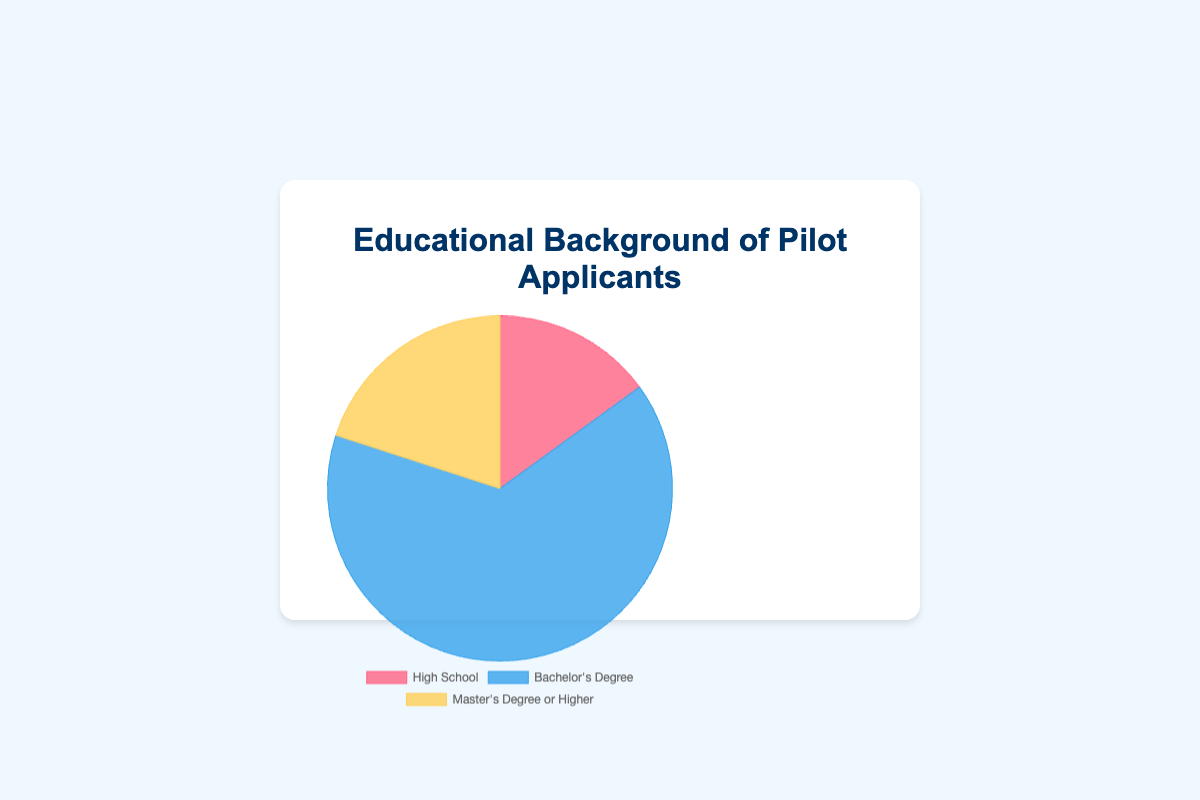What percentage of pilot applicants have at least a Bachelor's Degree? To find the percentage of applicants with at least a Bachelor's Degree, we need to sum the percentages of those with a Bachelor's Degree and those with a Master's Degree or Higher. Bachelor's Degree is 65% and Master's Degree or Higher is 20%, so the sum is 65% + 20% = 85%
Answer: 85% Which educational background has the highest percentage of pilot applicants? By comparing the given percentages, we see that the Bachelor's Degree category has the highest percentage of applicants at 65%
Answer: Bachelor's Degree How does the percentage of applicants with a Master's Degree or Higher compare to those with just a High School diploma? The percentage of applicants with a Master's Degree or Higher is 20%, while those with a High School diploma is 15%. Therefore, the percentage for Master's Degree or Higher is 5% higher.
Answer: 5% higher What is the proportion of applicants with a Bachelor's Degree to those with just a High School diploma? The percentage of applicants with a Bachelor's Degree is 65%, and with a High School diploma is 15%. To find the proportion, divide 65% by 15%, which gives approximately 4.33
Answer: 4.33 If the total number of applicants is 1,000, how many have a Master's Degree or Higher? To find the number of applicants with a Master's Degree or Higher, multiply 1,000 by 20% (the percentage for this category). This equals 1,000 * 0.20 = 200
Answer: 200 Which segment in the pie chart is represented by the color blue? By referring to the pie chart description, the Bachelor's Degree segment is represented by the color blue.
Answer: Bachelor's Degree What is the difference in percentage between the highest and lowest educational backgrounds? The highest percentage is for a Bachelor's Degree at 65%, and the lowest is for a High School diploma at 15%. The difference is 65% - 15% = 50%
Answer: 50% What is the total percentage of pilot applicants represented in the pie chart? Summing all the given percentages: 15% (High School) + 65% (Bachelor's Degree) + 20% (Master's Degree or Higher) = 100%
Answer: 100% What fraction of pilot applicants do not have a Bachelor’s Degree? The sum of the percentages for High School and Master's Degree or Higher is 15% + 20% = 35%. Thus, 35% of applicants do not have a Bachelor's Degree. Convert 35% to a fraction: 35/100, which simplifies to 7/20.
Answer: 7/20 Which segment has the lowest representation, and what color is it in the pie chart? The High School segment has the lowest representation at 15%, and it is represented by the color red.
Answer: High School, red 